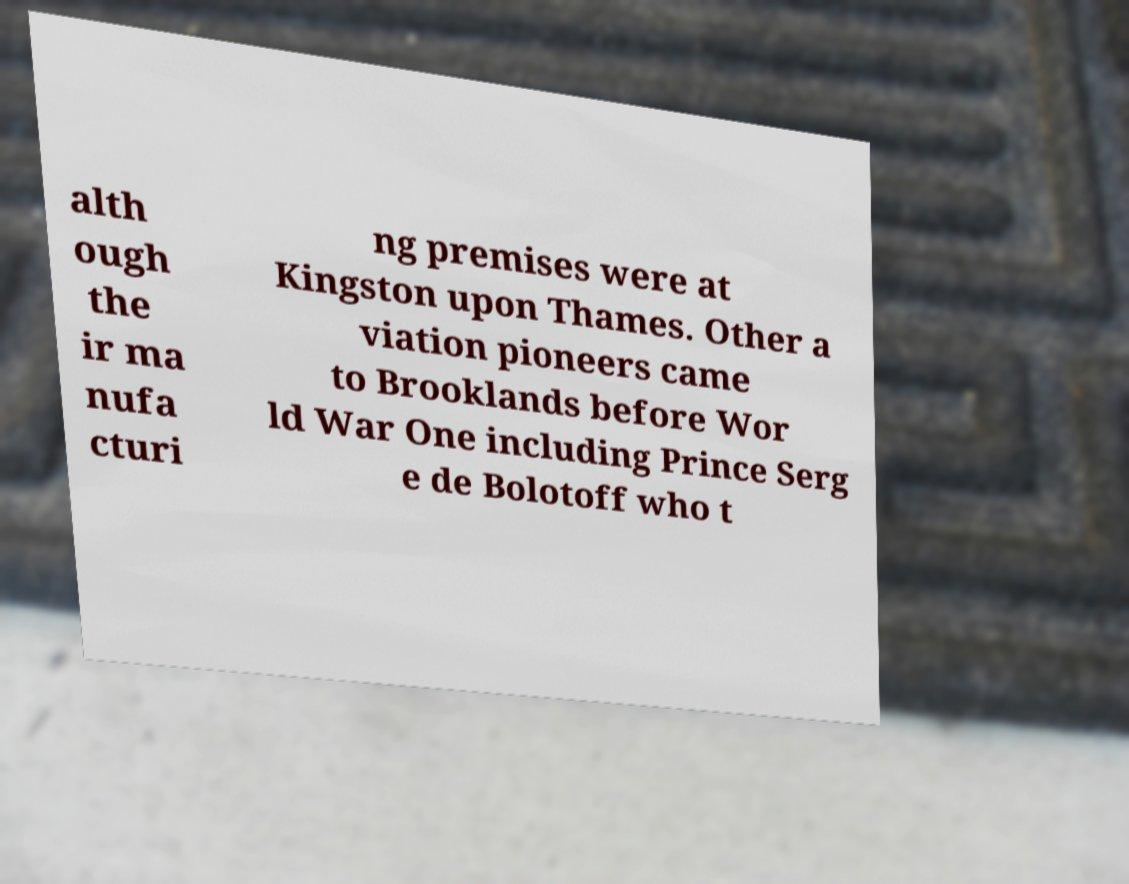For documentation purposes, I need the text within this image transcribed. Could you provide that? alth ough the ir ma nufa cturi ng premises were at Kingston upon Thames. Other a viation pioneers came to Brooklands before Wor ld War One including Prince Serg e de Bolotoff who t 